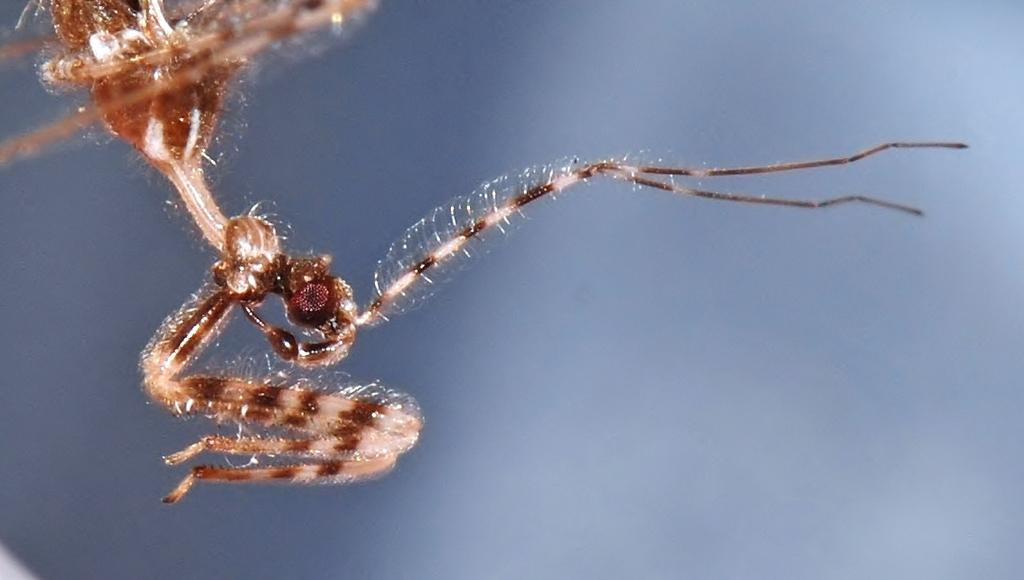What type of creature can be seen in the image? There is an insect in the image. Can you describe the background of the image? The background of the image is blurred. What type of respect can be seen in the image? There is no indication of respect in the image, as it features an insect and a blurred background. How many balloons are visible in the image? There are no balloons present in the image. 